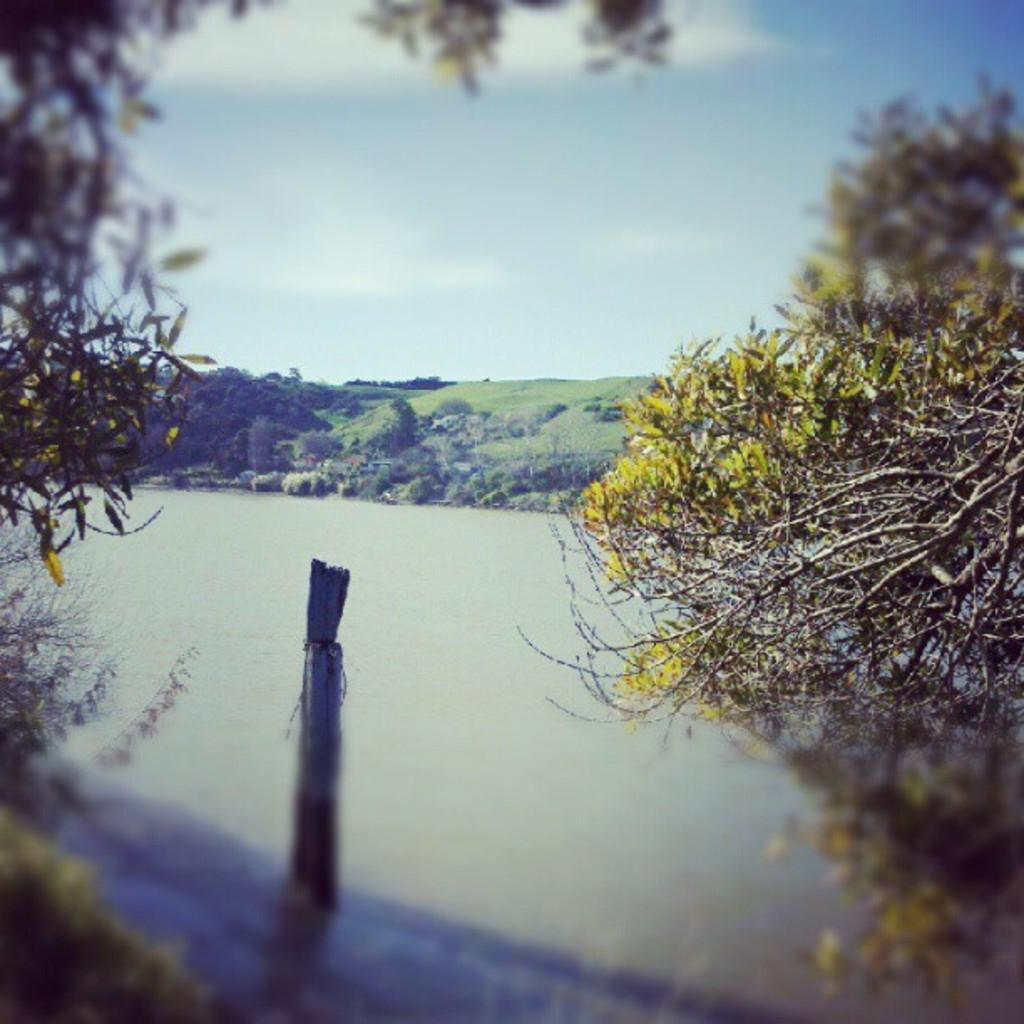What type of natural feature can be seen in the image? There is a river in the image. What type of vegetation is visible in the background of the image? There is grass in the background of the image. What type of geographical feature is visible in the background of the image? There is a mountain in the background of the image. What type of shelter is visible in the background of the image? There is a tent in the background of the image. What is visible at the top of the image? The sky is visible at the top of the image. What can be seen in the sky? Clouds are present in the sky. What type of vegetation is on the right side of the image? There are trees on the right side of the image. What type of comb is being used to groom the grass in the image? There is no comb present in the image, and the grass is not being groomed. 